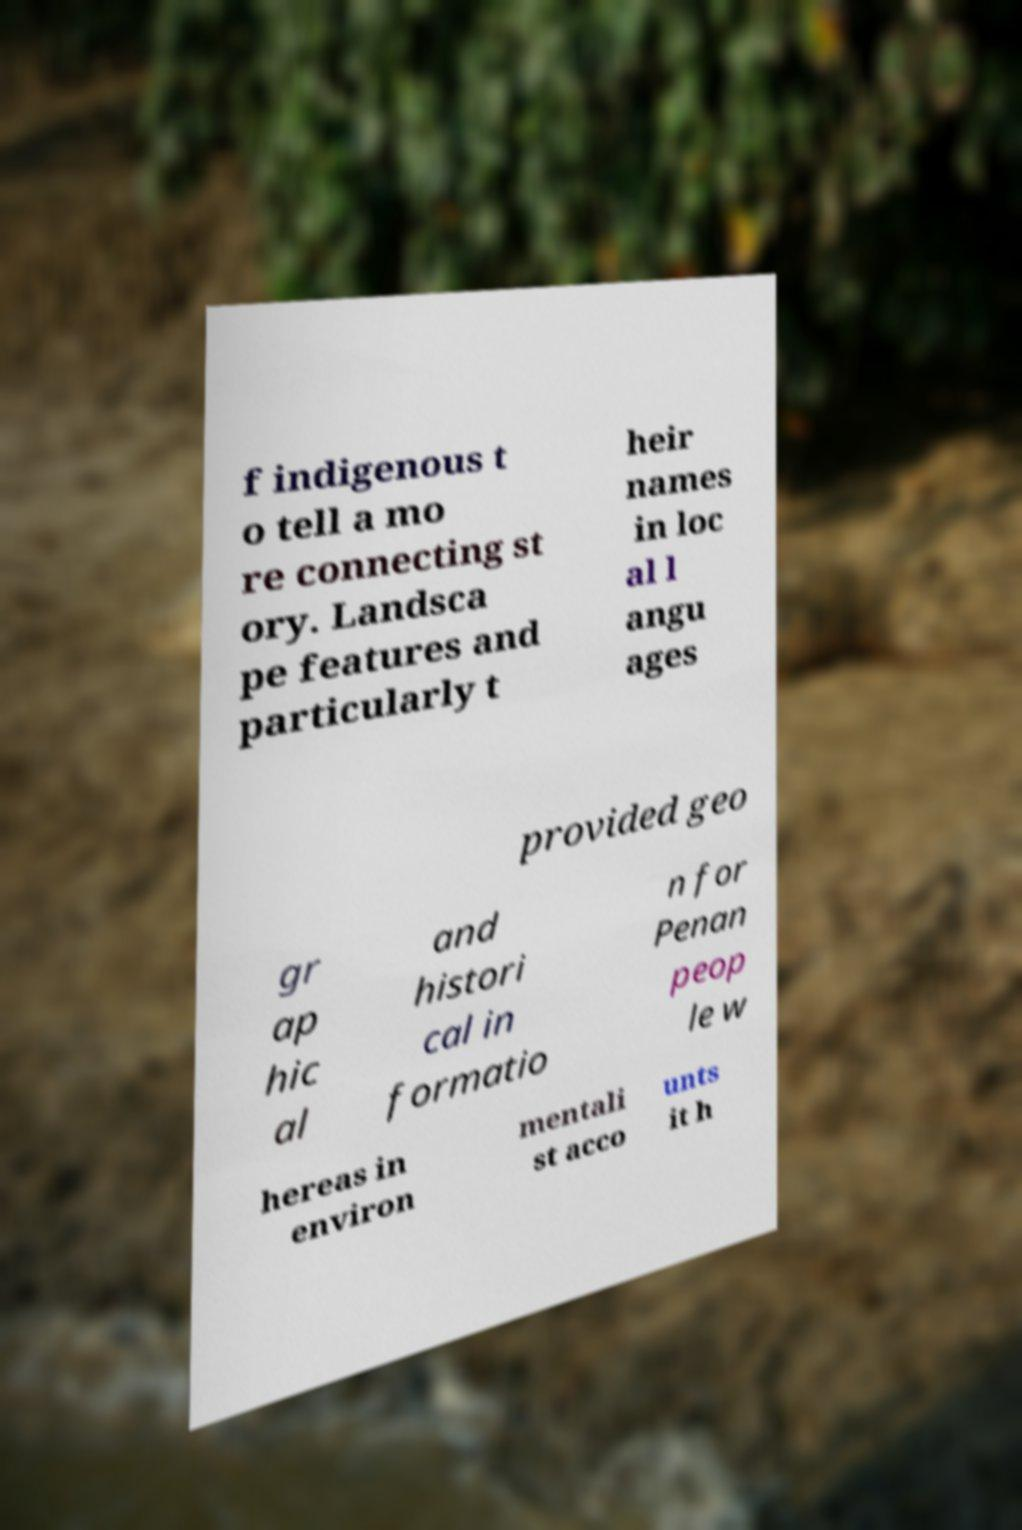Please identify and transcribe the text found in this image. f indigenous t o tell a mo re connecting st ory. Landsca pe features and particularly t heir names in loc al l angu ages provided geo gr ap hic al and histori cal in formatio n for Penan peop le w hereas in environ mentali st acco unts it h 